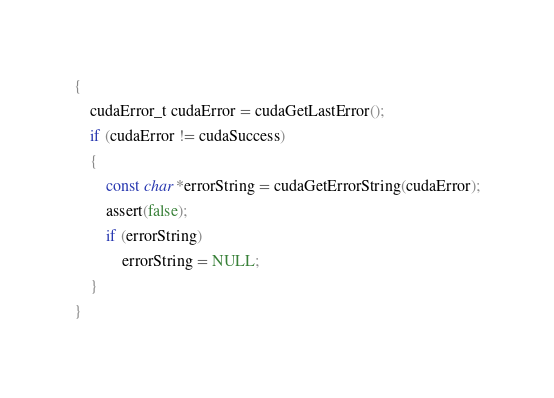Convert code to text. <code><loc_0><loc_0><loc_500><loc_500><_Cuda_>{	
	cudaError_t cudaError = cudaGetLastError();
	if (cudaError != cudaSuccess)
	{
		const char *errorString = cudaGetErrorString(cudaError);
		assert(false);
		if (errorString)
			errorString = NULL;
	}
}
</code> 